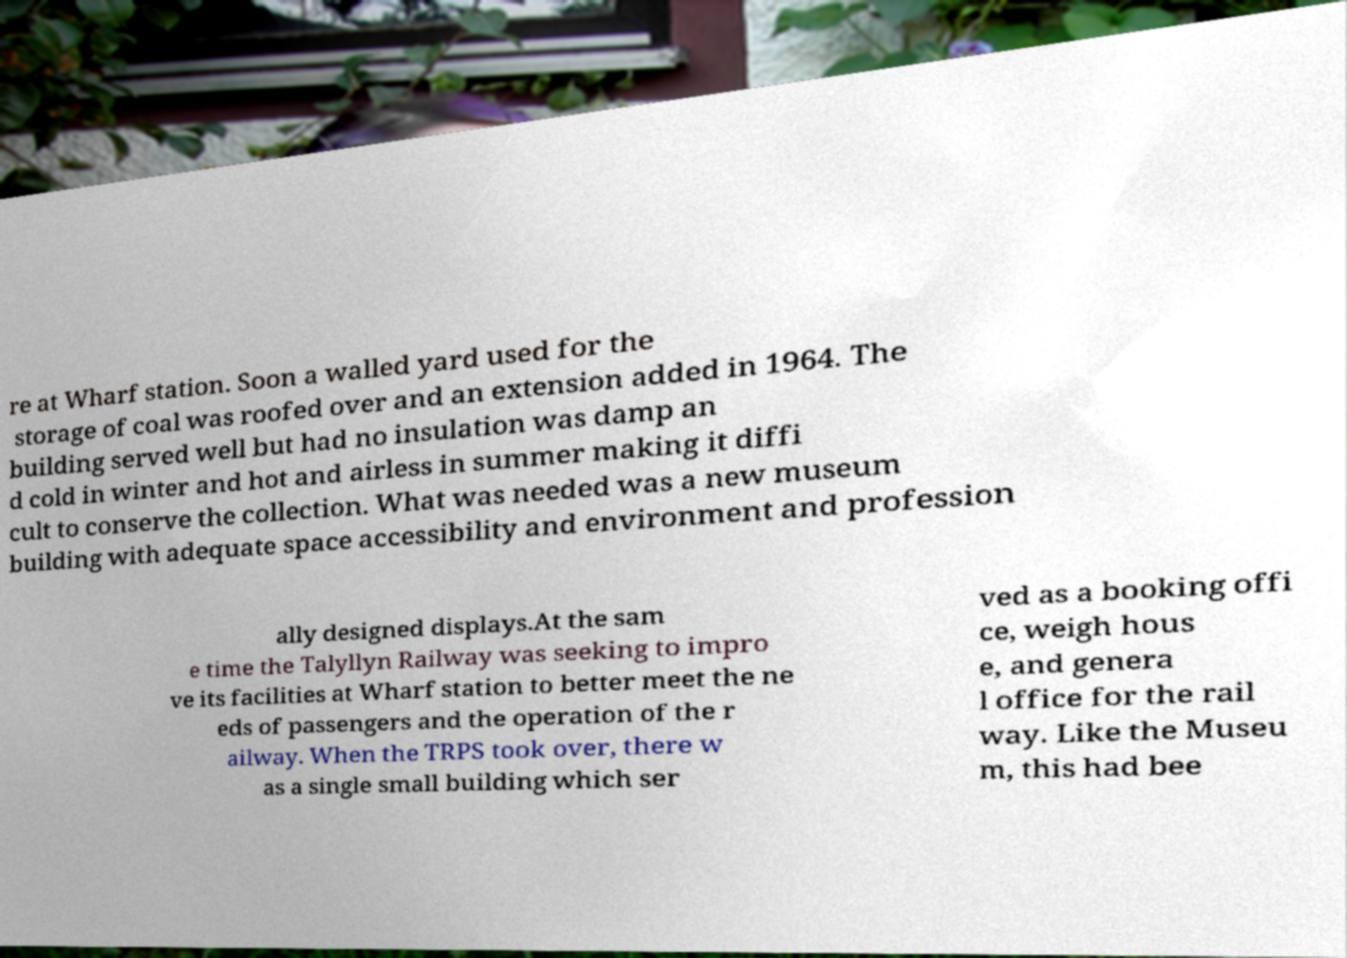Can you accurately transcribe the text from the provided image for me? re at Wharf station. Soon a walled yard used for the storage of coal was roofed over and an extension added in 1964. The building served well but had no insulation was damp an d cold in winter and hot and airless in summer making it diffi cult to conserve the collection. What was needed was a new museum building with adequate space accessibility and environment and profession ally designed displays.At the sam e time the Talyllyn Railway was seeking to impro ve its facilities at Wharf station to better meet the ne eds of passengers and the operation of the r ailway. When the TRPS took over, there w as a single small building which ser ved as a booking offi ce, weigh hous e, and genera l office for the rail way. Like the Museu m, this had bee 